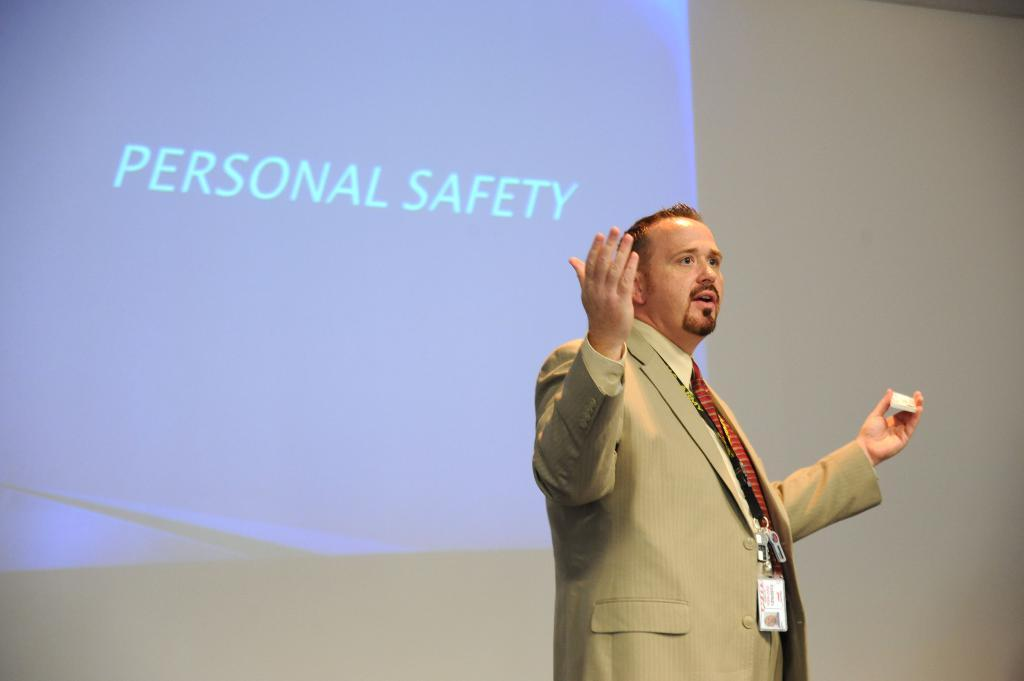What is happening on the stage in the image? There is a person on the stage in the image. What is the person holding in the image? The person is holding an object in the image. What can be seen on the screen in the image? There is text visible on a screen in the image. What type of cub can be seen playing with a pencil in the image? There is no cub or pencil present in the image. What force is being applied to the object held by the person in the image? The image does not provide information about any force being applied to the object held by the person. 